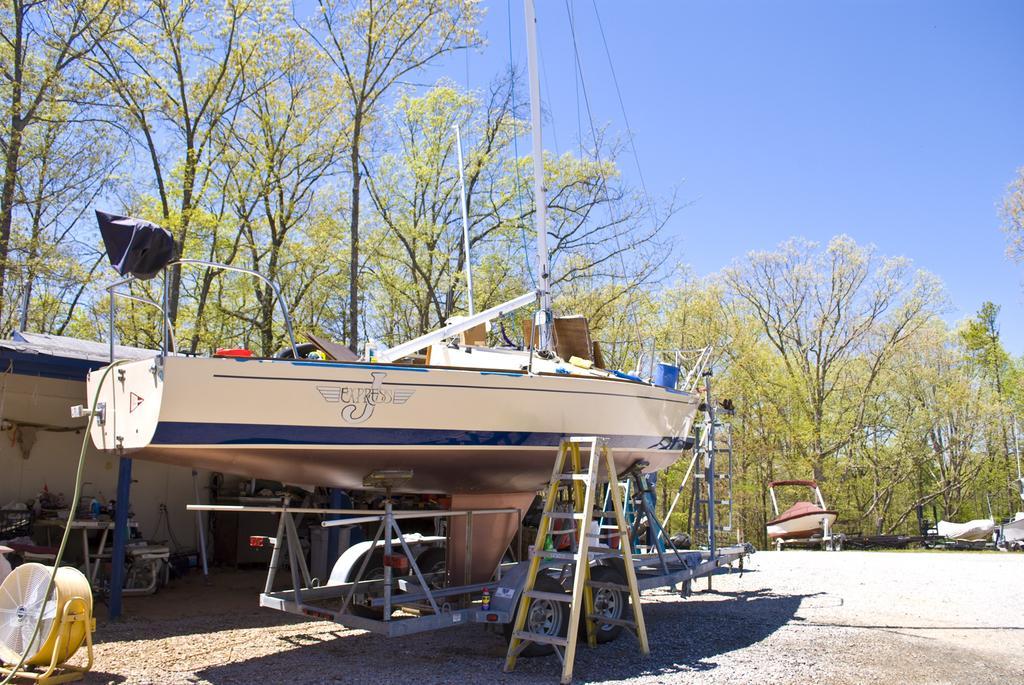Describe this image in one or two sentences. There is a boat on a stand. Near to that there is a ladder. In the back there is a building, trees and sky. 